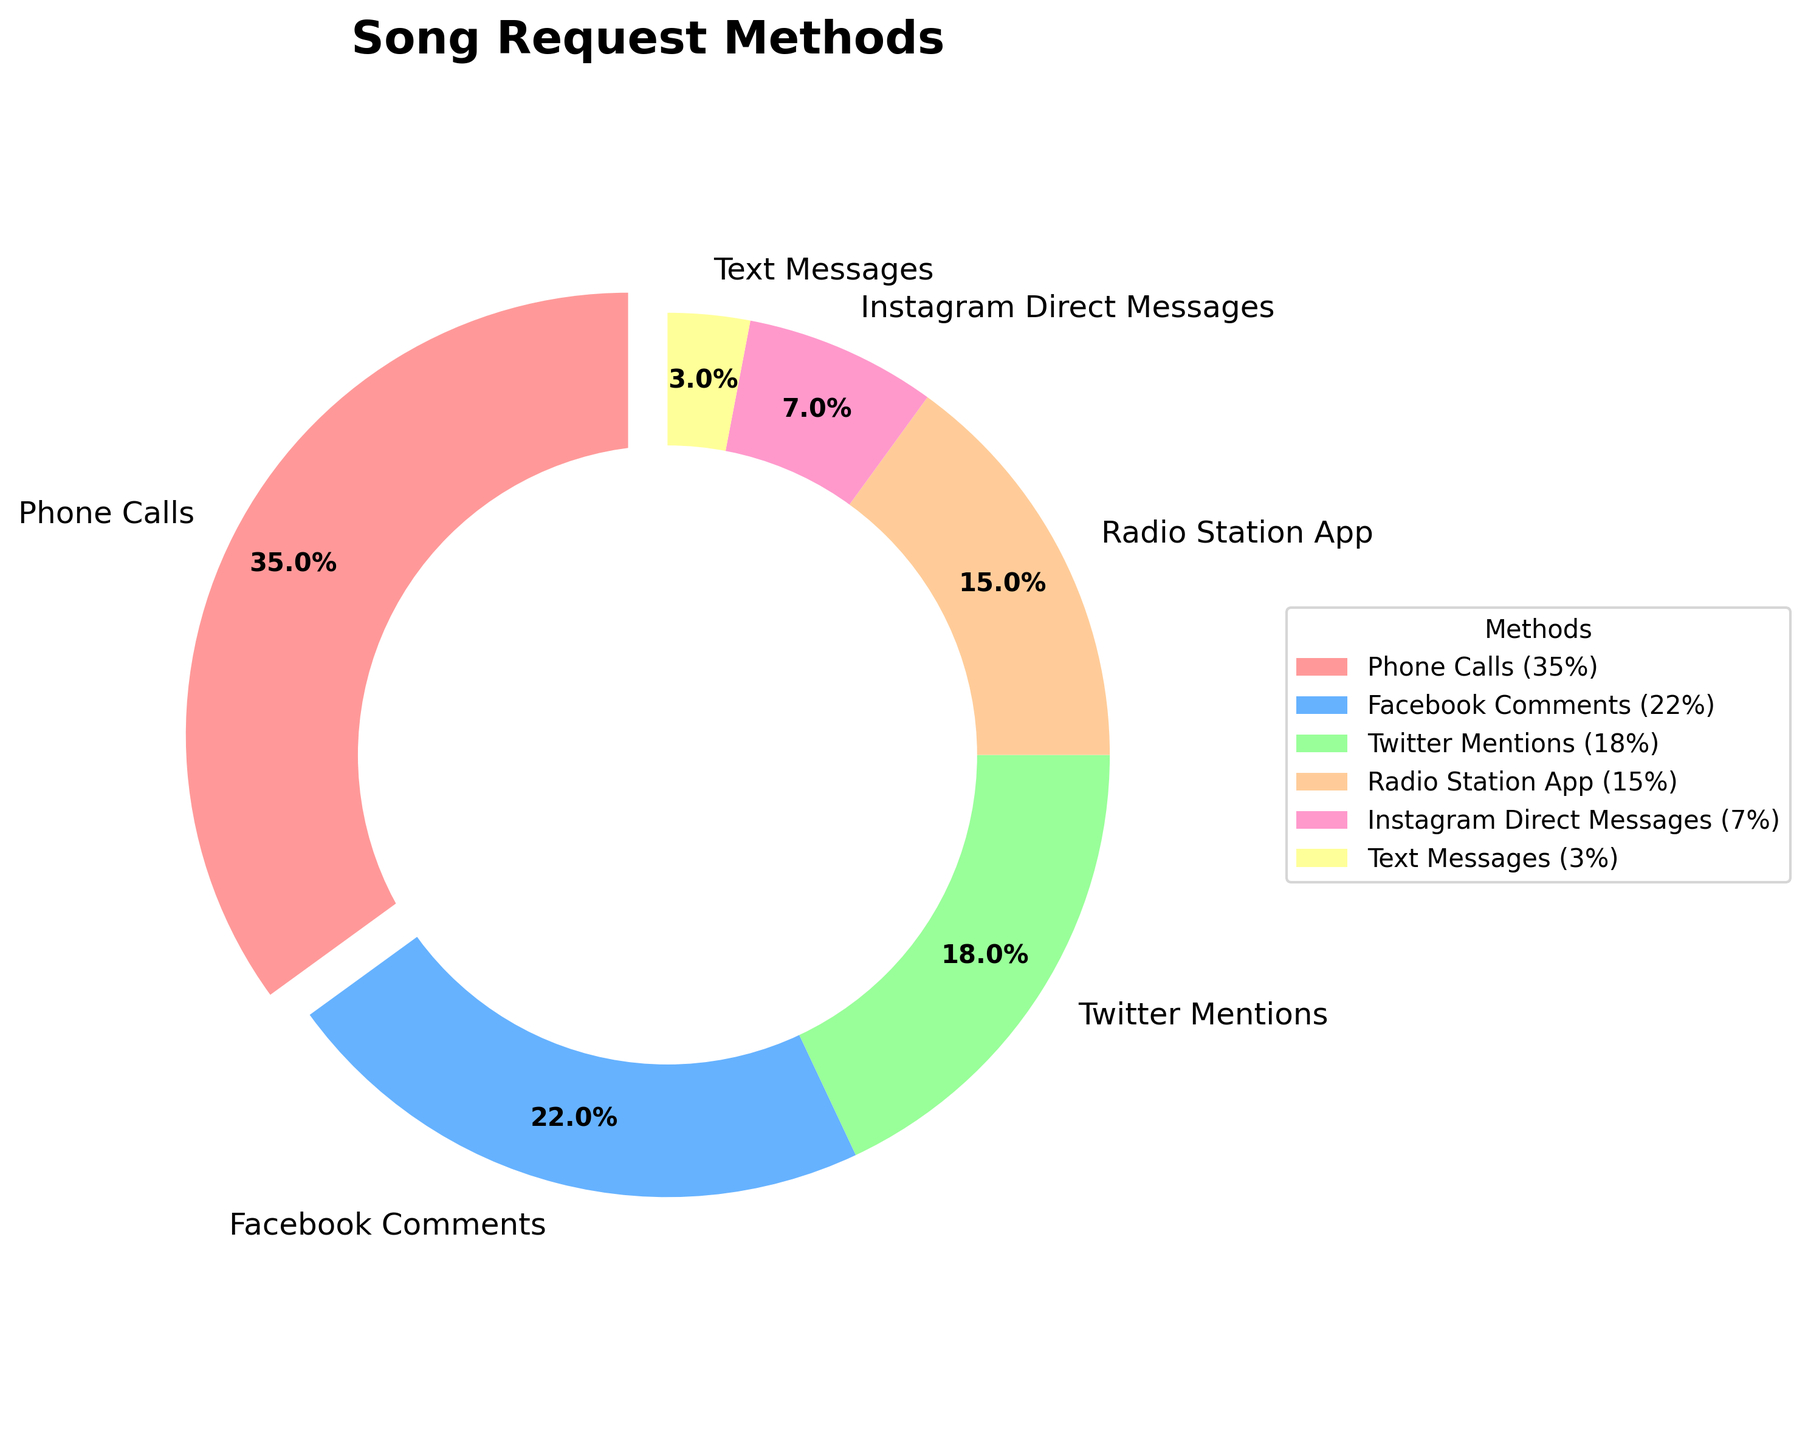what method has the highest usage for song requests? To find the most frequently used method for song requests, refer to the pie chart and identify the segment with the largest size. The legend and percentage labels will help confirm this.
Answer: Phone Calls What's the combined percentage of requests made through social media channels (Facebook Comments, Twitter Mentions, and Instagram Direct Messages)? Sum the percentages of the social media channels: 22% (Facebook Comments) + 18% (Twitter Mentions) + 7% (Instagram Direct Messages) = 47%.
Answer: 47% How much more frequently are requests made through Phone Calls compared to Text Messages? Subtract the percentage of Text Messages from Phone Calls: 35% (Phone Calls) - 3% (Text Messages) = 32%.
Answer: 32% Which method of engagement is used the least for song requests? Identify the smallest segment in the pie chart by observing the size and double-check with the percentage labels.
Answer: Text Messages What's the total percentage of requests that come from app-based methods (Radio Station App)? Look directly at the percentage provided for the Radio Station App in the pie chart.
Answer: 15% Compare the usage of the Radio Station App with Twitter Mentions. Which is used more, and by what percentage? Identify the percentages from the pie chart: Radio Station App 15%, Twitter Mentions 18%. Subtract Radio Station App percentage from Twitter Mentions: 18% - 15% = 3%. Twitter Mentions are used more by 3%.
Answer: Twitter Mentions by 3% What's the difference in percentage between Instagram Direct Messages and Facebook Comments? Subtract the percentage of Instagram Direct Messages from Facebook Comments: 22% (Facebook Comments) - 7% (Instagram Direct Messages) = 15%.
Answer: 15% If you combine the percentages of Instagram Direct Messages and Text Messages, how does this total compare to the percentage of Radio Station App usage? Sum the percentages of Instagram Direct Messages and Text Messages: 7% + 3% = 10%. Compare this with the Radio Station App, which is 15%. The combined total is less by 5%.
Answer: Less by 5% Which method covers a greater percentage: Phone Calls or the combined percentage of Facebook Comments and Twitter Mentions? Sum the percentages of Facebook Comments and Twitter Mentions: 22% + 18% = 40%. Compare this with Phone Calls, which is 35%. The combined percentage (40%) is greater by 5%.
Answer: Combined social media by 5% Are more song requests made through Phone Calls or through all methods excluding Phone Calls? Calculate the total percentage of all methods excluding Phone Calls (100% - 35%): 65%. Compare this with the percentage of Phone Calls, which is 35%. There are more requests made through all other methods combined.
Answer: Excluding Phone Calls 